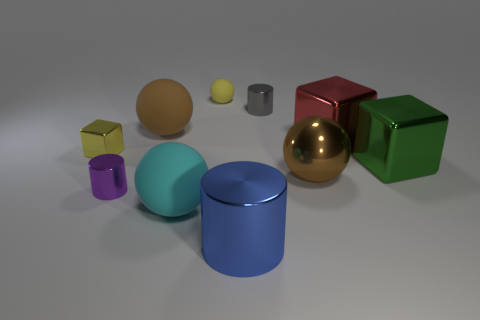Subtract all blocks. How many objects are left? 7 Add 7 big cyan objects. How many big cyan objects are left? 8 Add 8 purple cylinders. How many purple cylinders exist? 9 Subtract 0 blue balls. How many objects are left? 10 Subtract all things. Subtract all big gray spheres. How many objects are left? 0 